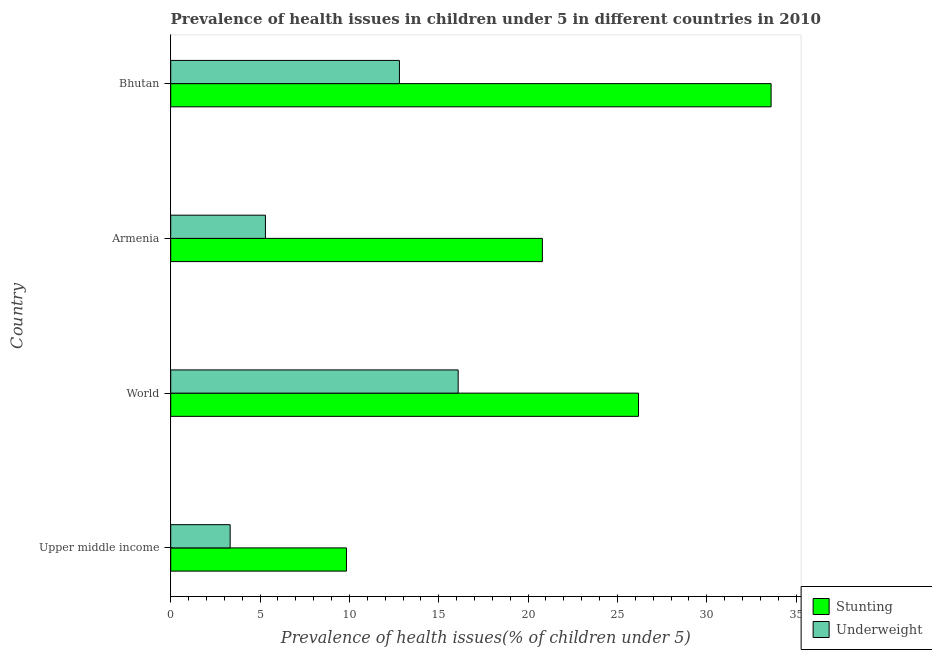How many different coloured bars are there?
Your response must be concise. 2. Are the number of bars on each tick of the Y-axis equal?
Your response must be concise. Yes. How many bars are there on the 3rd tick from the top?
Offer a terse response. 2. What is the label of the 4th group of bars from the top?
Your answer should be very brief. Upper middle income. What is the percentage of underweight children in Armenia?
Keep it short and to the point. 5.3. Across all countries, what is the maximum percentage of underweight children?
Give a very brief answer. 16.09. Across all countries, what is the minimum percentage of stunted children?
Provide a short and direct response. 9.84. In which country was the percentage of underweight children maximum?
Provide a succinct answer. World. In which country was the percentage of underweight children minimum?
Give a very brief answer. Upper middle income. What is the total percentage of underweight children in the graph?
Make the answer very short. 37.51. What is the difference between the percentage of underweight children in Armenia and that in World?
Make the answer very short. -10.79. What is the difference between the percentage of stunted children in Armenia and the percentage of underweight children in Upper middle income?
Ensure brevity in your answer.  17.47. What is the average percentage of stunted children per country?
Ensure brevity in your answer.  22.6. What is the difference between the percentage of underweight children and percentage of stunted children in Upper middle income?
Make the answer very short. -6.51. In how many countries, is the percentage of underweight children greater than 15 %?
Your answer should be very brief. 1. What is the ratio of the percentage of underweight children in Armenia to that in World?
Provide a short and direct response. 0.33. Is the difference between the percentage of stunted children in Armenia and Upper middle income greater than the difference between the percentage of underweight children in Armenia and Upper middle income?
Offer a terse response. Yes. What is the difference between the highest and the second highest percentage of underweight children?
Offer a terse response. 3.29. What is the difference between the highest and the lowest percentage of stunted children?
Make the answer very short. 23.76. Is the sum of the percentage of stunted children in Upper middle income and World greater than the maximum percentage of underweight children across all countries?
Make the answer very short. Yes. What does the 1st bar from the top in Armenia represents?
Provide a succinct answer. Underweight. What does the 1st bar from the bottom in Armenia represents?
Give a very brief answer. Stunting. How many bars are there?
Your answer should be compact. 8. How many countries are there in the graph?
Your response must be concise. 4. What is the difference between two consecutive major ticks on the X-axis?
Provide a succinct answer. 5. Does the graph contain any zero values?
Your answer should be compact. No. Does the graph contain grids?
Make the answer very short. No. How are the legend labels stacked?
Keep it short and to the point. Vertical. What is the title of the graph?
Ensure brevity in your answer.  Prevalence of health issues in children under 5 in different countries in 2010. What is the label or title of the X-axis?
Give a very brief answer. Prevalence of health issues(% of children under 5). What is the Prevalence of health issues(% of children under 5) in Stunting in Upper middle income?
Your answer should be compact. 9.84. What is the Prevalence of health issues(% of children under 5) of Underweight in Upper middle income?
Your answer should be very brief. 3.33. What is the Prevalence of health issues(% of children under 5) in Stunting in World?
Give a very brief answer. 26.18. What is the Prevalence of health issues(% of children under 5) of Underweight in World?
Your answer should be very brief. 16.09. What is the Prevalence of health issues(% of children under 5) of Stunting in Armenia?
Your answer should be compact. 20.8. What is the Prevalence of health issues(% of children under 5) of Underweight in Armenia?
Your response must be concise. 5.3. What is the Prevalence of health issues(% of children under 5) of Stunting in Bhutan?
Your answer should be compact. 33.6. What is the Prevalence of health issues(% of children under 5) of Underweight in Bhutan?
Offer a very short reply. 12.8. Across all countries, what is the maximum Prevalence of health issues(% of children under 5) in Stunting?
Your answer should be compact. 33.6. Across all countries, what is the maximum Prevalence of health issues(% of children under 5) in Underweight?
Ensure brevity in your answer.  16.09. Across all countries, what is the minimum Prevalence of health issues(% of children under 5) in Stunting?
Ensure brevity in your answer.  9.84. Across all countries, what is the minimum Prevalence of health issues(% of children under 5) of Underweight?
Your response must be concise. 3.33. What is the total Prevalence of health issues(% of children under 5) in Stunting in the graph?
Make the answer very short. 90.42. What is the total Prevalence of health issues(% of children under 5) of Underweight in the graph?
Make the answer very short. 37.51. What is the difference between the Prevalence of health issues(% of children under 5) in Stunting in Upper middle income and that in World?
Give a very brief answer. -16.34. What is the difference between the Prevalence of health issues(% of children under 5) of Underweight in Upper middle income and that in World?
Your response must be concise. -12.76. What is the difference between the Prevalence of health issues(% of children under 5) in Stunting in Upper middle income and that in Armenia?
Provide a short and direct response. -10.96. What is the difference between the Prevalence of health issues(% of children under 5) of Underweight in Upper middle income and that in Armenia?
Your answer should be very brief. -1.97. What is the difference between the Prevalence of health issues(% of children under 5) of Stunting in Upper middle income and that in Bhutan?
Offer a very short reply. -23.76. What is the difference between the Prevalence of health issues(% of children under 5) of Underweight in Upper middle income and that in Bhutan?
Provide a succinct answer. -9.47. What is the difference between the Prevalence of health issues(% of children under 5) of Stunting in World and that in Armenia?
Your response must be concise. 5.38. What is the difference between the Prevalence of health issues(% of children under 5) in Underweight in World and that in Armenia?
Make the answer very short. 10.79. What is the difference between the Prevalence of health issues(% of children under 5) of Stunting in World and that in Bhutan?
Offer a very short reply. -7.42. What is the difference between the Prevalence of health issues(% of children under 5) of Underweight in World and that in Bhutan?
Offer a terse response. 3.29. What is the difference between the Prevalence of health issues(% of children under 5) in Stunting in Armenia and that in Bhutan?
Make the answer very short. -12.8. What is the difference between the Prevalence of health issues(% of children under 5) in Stunting in Upper middle income and the Prevalence of health issues(% of children under 5) in Underweight in World?
Your answer should be compact. -6.25. What is the difference between the Prevalence of health issues(% of children under 5) of Stunting in Upper middle income and the Prevalence of health issues(% of children under 5) of Underweight in Armenia?
Your response must be concise. 4.54. What is the difference between the Prevalence of health issues(% of children under 5) in Stunting in Upper middle income and the Prevalence of health issues(% of children under 5) in Underweight in Bhutan?
Your answer should be very brief. -2.96. What is the difference between the Prevalence of health issues(% of children under 5) of Stunting in World and the Prevalence of health issues(% of children under 5) of Underweight in Armenia?
Ensure brevity in your answer.  20.88. What is the difference between the Prevalence of health issues(% of children under 5) in Stunting in World and the Prevalence of health issues(% of children under 5) in Underweight in Bhutan?
Give a very brief answer. 13.38. What is the average Prevalence of health issues(% of children under 5) of Stunting per country?
Give a very brief answer. 22.6. What is the average Prevalence of health issues(% of children under 5) in Underweight per country?
Ensure brevity in your answer.  9.38. What is the difference between the Prevalence of health issues(% of children under 5) in Stunting and Prevalence of health issues(% of children under 5) in Underweight in Upper middle income?
Offer a terse response. 6.51. What is the difference between the Prevalence of health issues(% of children under 5) of Stunting and Prevalence of health issues(% of children under 5) of Underweight in World?
Make the answer very short. 10.09. What is the difference between the Prevalence of health issues(% of children under 5) in Stunting and Prevalence of health issues(% of children under 5) in Underweight in Armenia?
Offer a terse response. 15.5. What is the difference between the Prevalence of health issues(% of children under 5) in Stunting and Prevalence of health issues(% of children under 5) in Underweight in Bhutan?
Ensure brevity in your answer.  20.8. What is the ratio of the Prevalence of health issues(% of children under 5) in Stunting in Upper middle income to that in World?
Offer a terse response. 0.38. What is the ratio of the Prevalence of health issues(% of children under 5) in Underweight in Upper middle income to that in World?
Offer a very short reply. 0.21. What is the ratio of the Prevalence of health issues(% of children under 5) of Stunting in Upper middle income to that in Armenia?
Offer a terse response. 0.47. What is the ratio of the Prevalence of health issues(% of children under 5) in Underweight in Upper middle income to that in Armenia?
Provide a short and direct response. 0.63. What is the ratio of the Prevalence of health issues(% of children under 5) in Stunting in Upper middle income to that in Bhutan?
Make the answer very short. 0.29. What is the ratio of the Prevalence of health issues(% of children under 5) in Underweight in Upper middle income to that in Bhutan?
Keep it short and to the point. 0.26. What is the ratio of the Prevalence of health issues(% of children under 5) of Stunting in World to that in Armenia?
Your answer should be very brief. 1.26. What is the ratio of the Prevalence of health issues(% of children under 5) in Underweight in World to that in Armenia?
Provide a succinct answer. 3.04. What is the ratio of the Prevalence of health issues(% of children under 5) of Stunting in World to that in Bhutan?
Offer a terse response. 0.78. What is the ratio of the Prevalence of health issues(% of children under 5) in Underweight in World to that in Bhutan?
Your answer should be compact. 1.26. What is the ratio of the Prevalence of health issues(% of children under 5) in Stunting in Armenia to that in Bhutan?
Offer a terse response. 0.62. What is the ratio of the Prevalence of health issues(% of children under 5) of Underweight in Armenia to that in Bhutan?
Your answer should be compact. 0.41. What is the difference between the highest and the second highest Prevalence of health issues(% of children under 5) in Stunting?
Keep it short and to the point. 7.42. What is the difference between the highest and the second highest Prevalence of health issues(% of children under 5) of Underweight?
Make the answer very short. 3.29. What is the difference between the highest and the lowest Prevalence of health issues(% of children under 5) of Stunting?
Ensure brevity in your answer.  23.76. What is the difference between the highest and the lowest Prevalence of health issues(% of children under 5) of Underweight?
Keep it short and to the point. 12.76. 